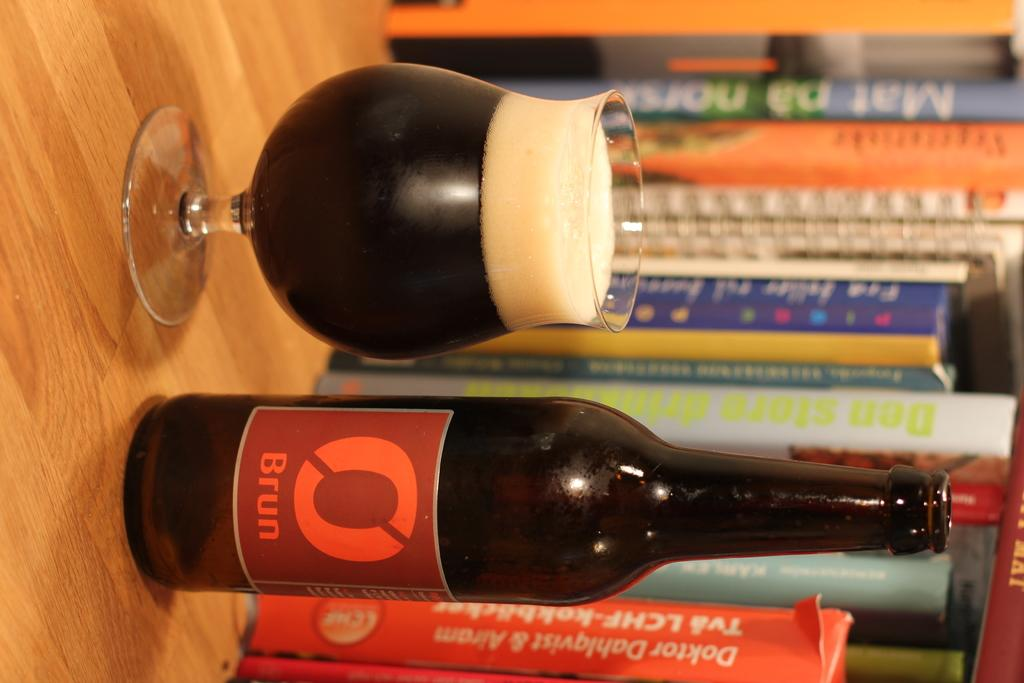Provide a one-sentence caption for the provided image. A bottle of Brun beer is poured into a glass by some books. 